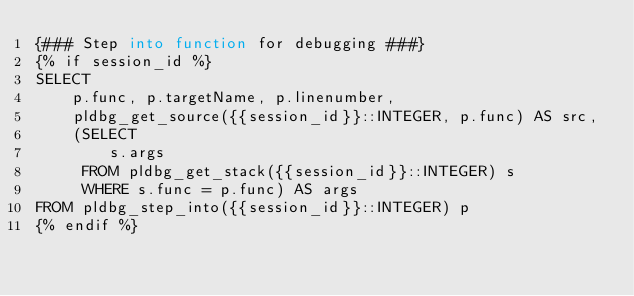<code> <loc_0><loc_0><loc_500><loc_500><_SQL_>{### Step into function for debugging ###}
{% if session_id %}
SELECT
    p.func, p.targetName, p.linenumber,
    pldbg_get_source({{session_id}}::INTEGER, p.func) AS src,
    (SELECT
        s.args
     FROM pldbg_get_stack({{session_id}}::INTEGER) s
     WHERE s.func = p.func) AS args
FROM pldbg_step_into({{session_id}}::INTEGER) p
{% endif %}</code> 